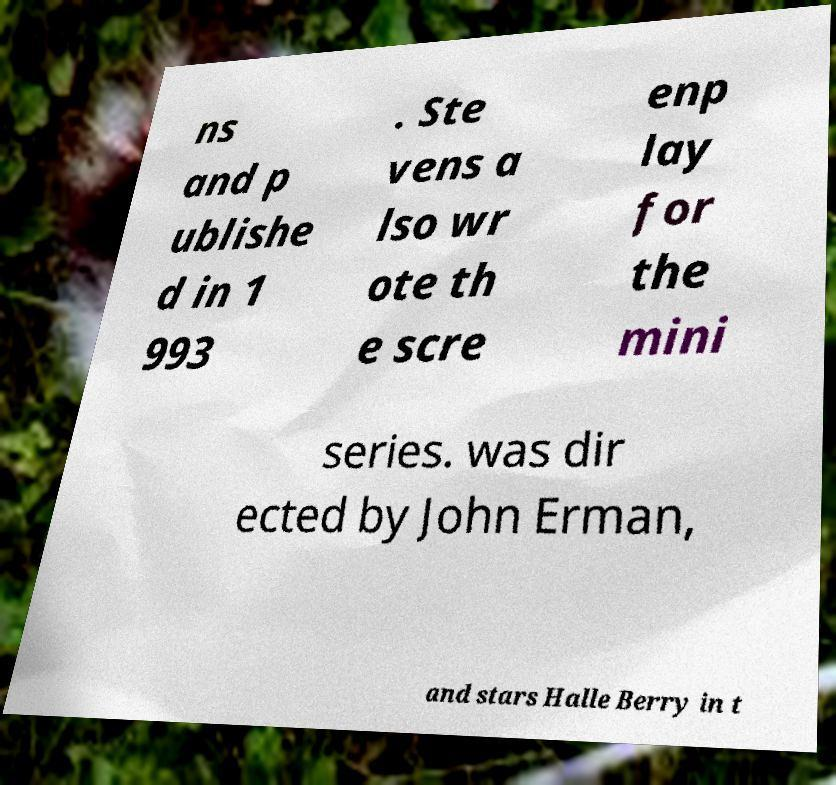Can you read and provide the text displayed in the image?This photo seems to have some interesting text. Can you extract and type it out for me? ns and p ublishe d in 1 993 . Ste vens a lso wr ote th e scre enp lay for the mini series. was dir ected by John Erman, and stars Halle Berry in t 